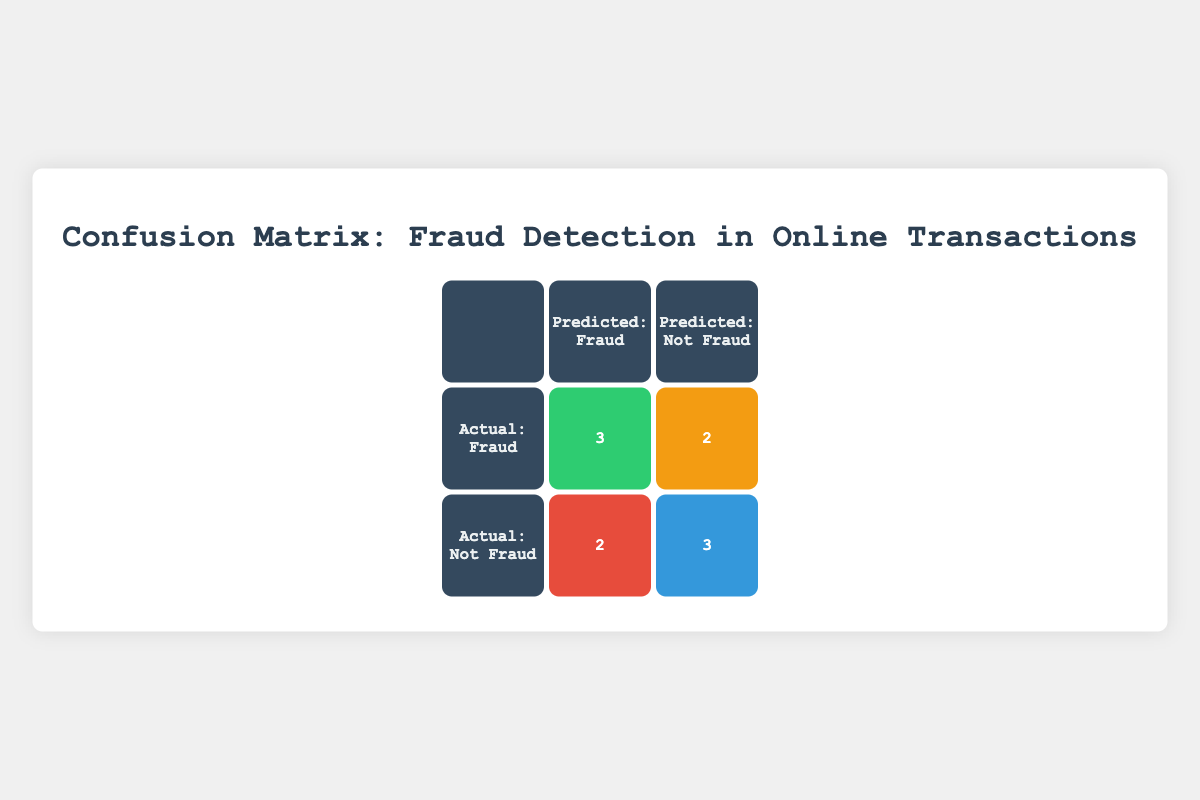What is the total number of true positives in the matrix? The total number of true positives is found in the True Positive cell, which is represented by the count of correctly predicted fraud cases. In the table according to the derived data, this value is 4.
Answer: 4 What is the number of false positives in the confusion matrix? The number of false positives is located in the False Positive cell, which counts the cases incorrectly predicted as fraud when they are not. In the table, this value is 3.
Answer: 3 Is the number of true negatives greater than the number of false negatives? The number of true negatives is 3, and the number of false negatives is 1. Since 3 is greater than 1, the answer is yes.
Answer: Yes What is the total count of all predictions in the matrix? The total count of predictions can be calculated by adding all the values in the confusion matrix. From the table: true positives (4) + false negatives (1) + false positives (3) + true negatives (3) equals 11 in total.
Answer: 11 How many actual fraud cases were correctly predicted as fraud? This value is also the true positive count from the confusion matrix. Since 4 cases were both actual and predicted as fraud, the answer is 4.
Answer: 4 Are the false negatives equal to the true negatives? From the table, false negatives are 1 and true negatives are 3. Since these values are not equal, the answer is no.
Answer: No What is the value of false negatives plus true positives? To find this value, we add the false negatives (1) and true positives (4) together. Therefore, the sum is 1 + 4 = 5.
Answer: 5 What percentage of all transactions were correctly predicted as not fraud? The percentage of correctly predicted as not fraud is calculated by taking true negatives (3) divided by the total predictions (11), then multiplied by 100. Therefore, (3/11) * 100 = 27.27%.
Answer: 27.27% How many cases were predicted as fraud but were actually not fraud? The number of cases predicted as fraud but were actually not fraud corresponds to the false positive count, which is 3 according to the matrix.
Answer: 3 